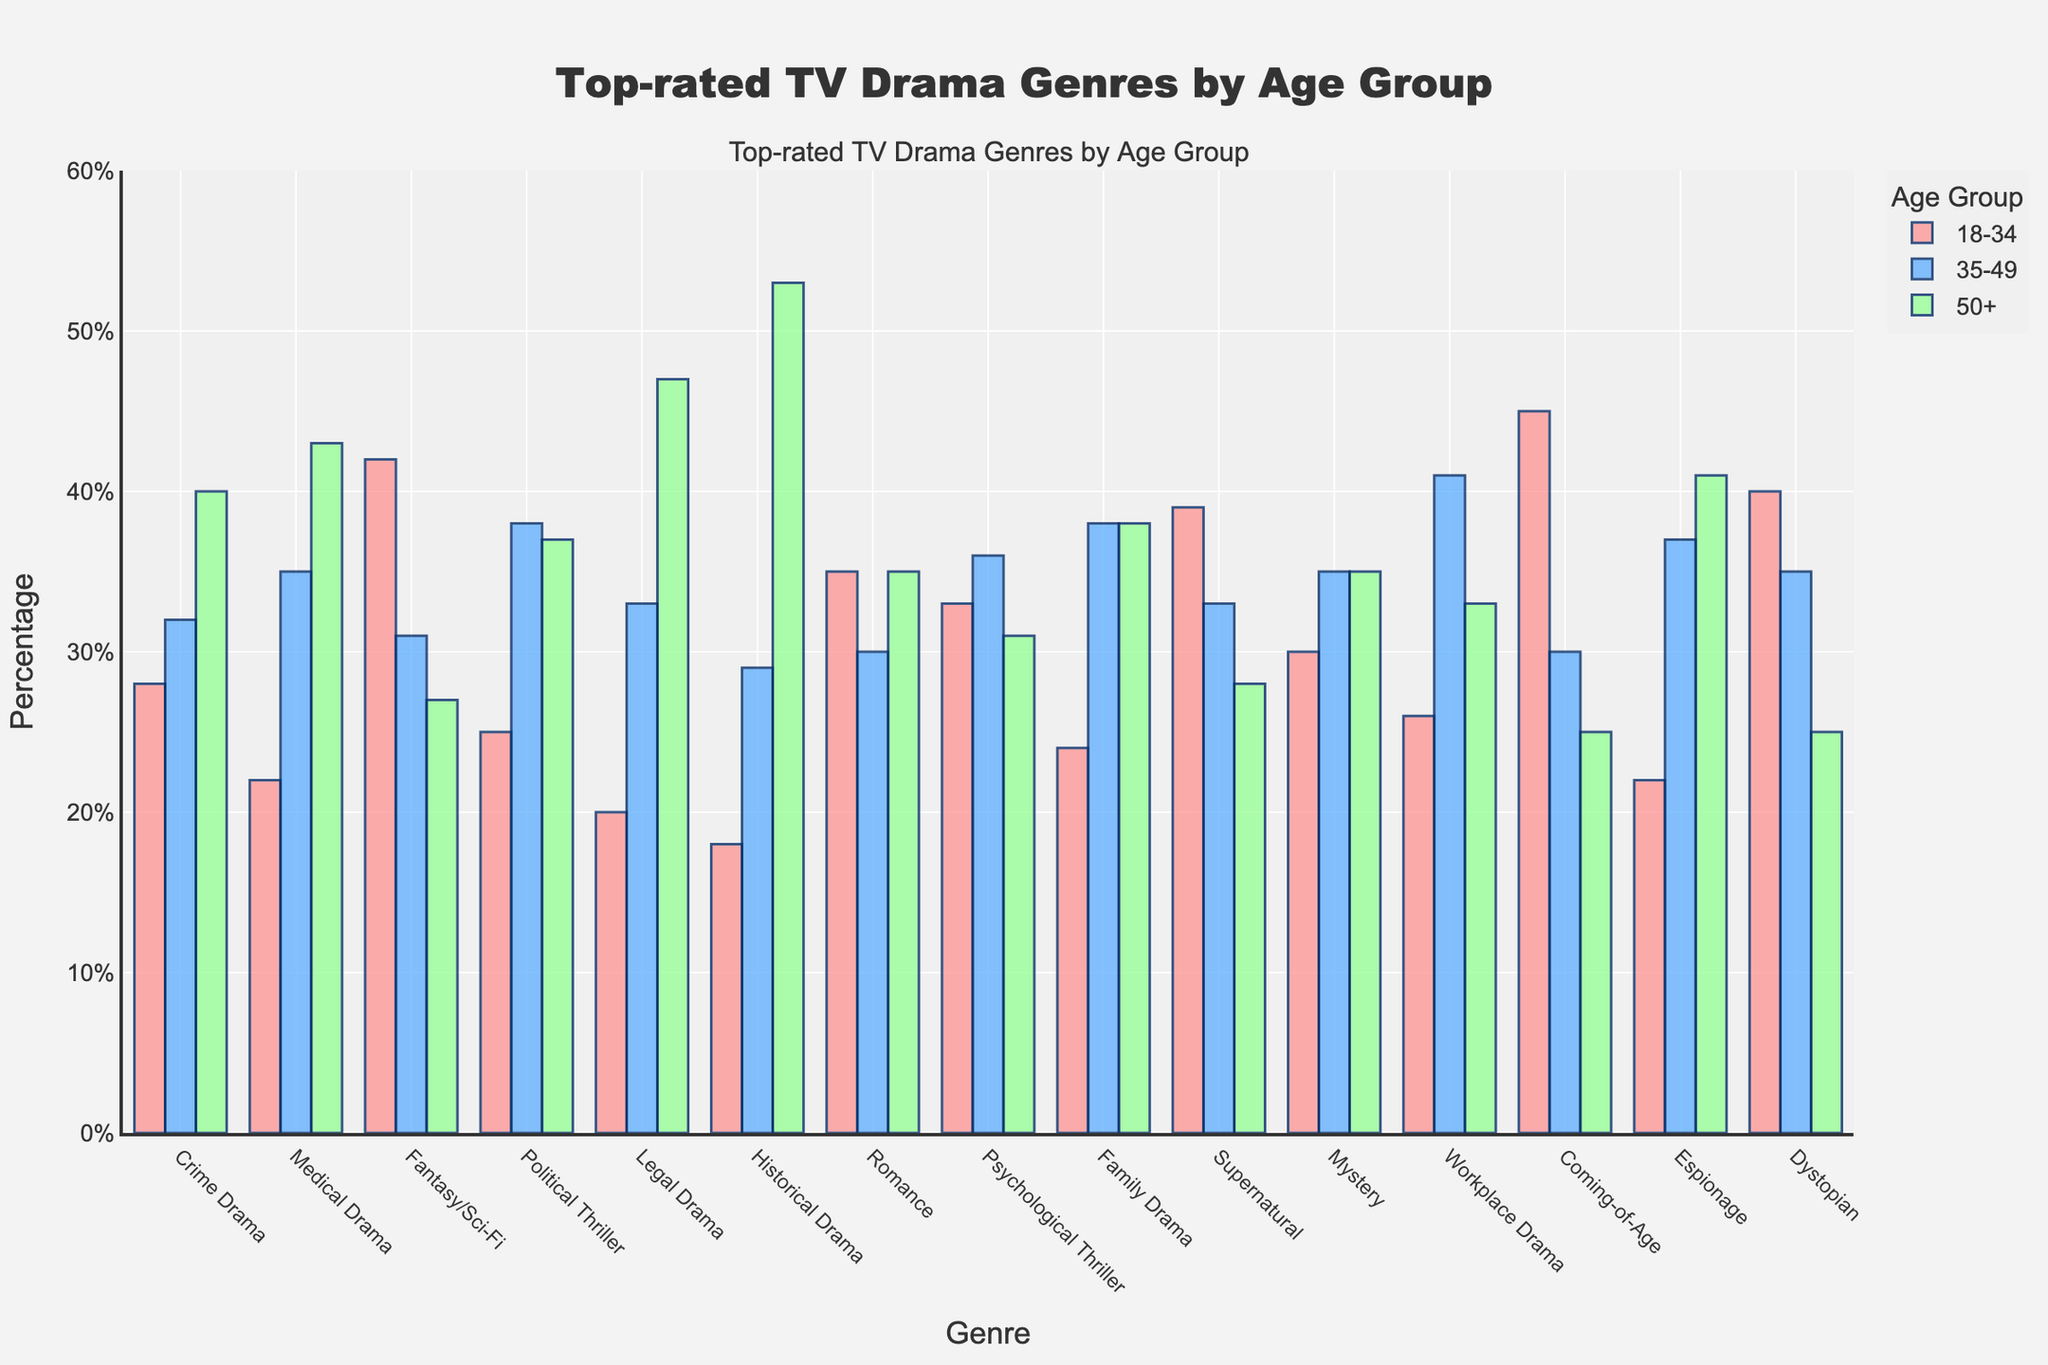Which genre has the highest percentage of 18-34 viewers? By looking at the height of the bars for the 18-34 age group, we identify the genre with the tallest bar in that category. "Coming-of-Age" has the highest percentage in the 18-34 age group.
Answer: Coming-of-Age Which genre is most popular among the 50+ age group? Observing the bars for the 50+ age group, we look for the tallest bar. "Historical Drama" has the highest percentage in the 50+ age group.
Answer: Historical Drama Which age group has the highest viewership for Fantasy/Sci-Fi? We examine the bars representing the 18-34, 35-49, and 50+ age groups for Fantasy/Sci-Fi. The 18-34 age group has the highest bar for Fantasy/Sci-Fi.
Answer: 18-34 Is there any genre where the 35-49 age group has the highest viewership compared to the other age groups? We compare the height of the bars for the 18-34, 35-49, and 50+ age groups for each genre. "Medical Drama" has the highest viewership in the 35-49 age group compared to the other age groups.
Answer: Medical Drama What is the average percentage of 18-34 viewers for Romance, Psychological Thriller, and Supernatural? To find the average, sum the percentages for the 18-34 viewers in Romance, Psychological Thriller, and Supernatural and divide by the number of genres. (35 + 33 + 39) / 3 = 35.67.
Answer: 35.67 Which genre has the least percentage of viewers in the 18-34 age group? By identifying the shortest bar in the 18-34 age group, we find "Historical Drama" has the least percentage of viewers.
Answer: Historical Drama Compare the viewership of Family Drama and Political Thriller among the 35-49 age group. Which has more viewers? By comparing the heights of the bars representing the 35-49 age group for both genres, Family Drama has the same percentage of viewers as Political Thriller.
Answer: Same What’s the sum of the percentages of viewers aged 50+ for Legal Drama and Medical Drama? Add the percentages for viewers aged 50+ in Legal Drama and Medical Drama. 47 + 43 = 90.
Answer: 90 Which genre has an equal percentage of viewers in the 50+ age group? By examining the 50+ age group, we notice that both "Family Drama" and "Mystery" have the same percentage of viewers.
Answer: Family Drama and Mystery Calculate the difference in viewership between 18-34 and 50+ for Dystopian dramas. Subtract the percentage for the 50+ age group from the percentage for the 18-34 age group for Dystopian dramas. 40 - 25 = 15.
Answer: 15 